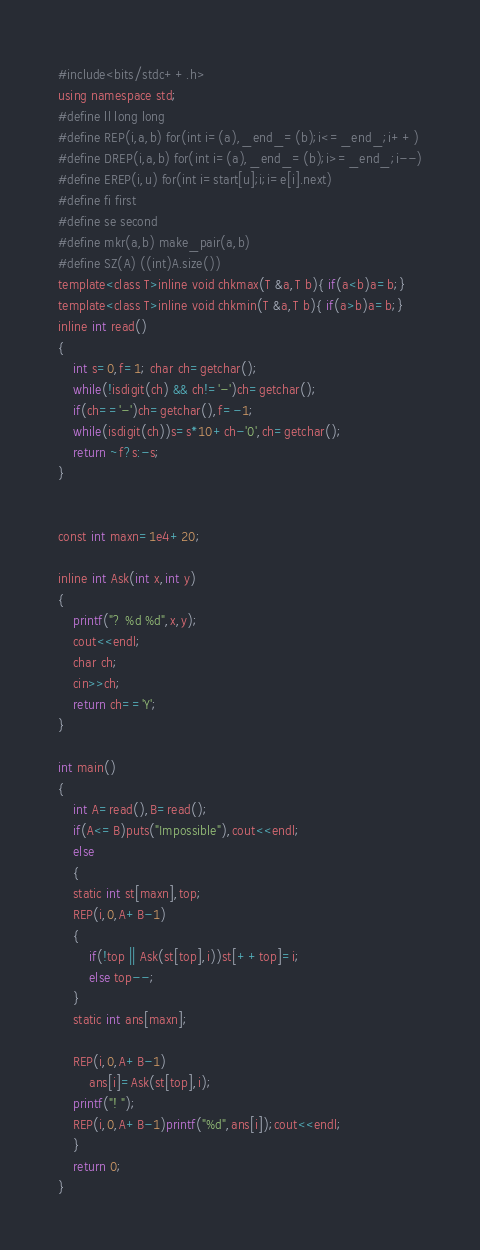<code> <loc_0><loc_0><loc_500><loc_500><_Awk_>#include<bits/stdc++.h>
using namespace std;
#define ll long long
#define REP(i,a,b) for(int i=(a),_end_=(b);i<=_end_;i++)
#define DREP(i,a,b) for(int i=(a),_end_=(b);i>=_end_;i--)
#define EREP(i,u) for(int i=start[u];i;i=e[i].next)
#define fi first
#define se second
#define mkr(a,b) make_pair(a,b)
#define SZ(A) ((int)A.size())
template<class T>inline void chkmax(T &a,T b){ if(a<b)a=b;}
template<class T>inline void chkmin(T &a,T b){ if(a>b)a=b;}
inline int read()
{
    int s=0,f=1; char ch=getchar();
    while(!isdigit(ch) && ch!='-')ch=getchar();
    if(ch=='-')ch=getchar(),f=-1;
    while(isdigit(ch))s=s*10+ch-'0',ch=getchar();
    return ~f?s:-s;
}


const int maxn=1e4+20;

inline int Ask(int x,int y)
{
    printf("? %d %d",x,y);
    cout<<endl;
    char ch;
    cin>>ch;
    return ch=='Y';
}

int main()
{
    int A=read(),B=read();
    if(A<=B)puts("Impossible"),cout<<endl;
    else
    {
	static int st[maxn],top;
	REP(i,0,A+B-1)
	{
	    if(!top || Ask(st[top],i))st[++top]=i;
	    else top--;
	}
	static int ans[maxn];
	
	REP(i,0,A+B-1)
	    ans[i]=Ask(st[top],i);
	printf("! ");
	REP(i,0,A+B-1)printf("%d",ans[i]);cout<<endl;
    }
    return 0;
}
</code> 